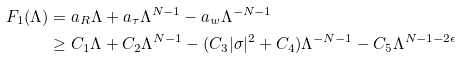Convert formula to latex. <formula><loc_0><loc_0><loc_500><loc_500>F _ { 1 } ( \Lambda ) & = a _ { R } \Lambda + a _ { \tau } \Lambda ^ { N - 1 } - a _ { w } \Lambda ^ { - N - 1 } \\ & \geq C _ { 1 } \Lambda + C _ { 2 } \Lambda ^ { N - 1 } - ( C _ { 3 } | \sigma | ^ { 2 } + C _ { 4 } ) \Lambda ^ { - N - 1 } - C _ { 5 } \Lambda ^ { N - 1 - 2 \epsilon }</formula> 